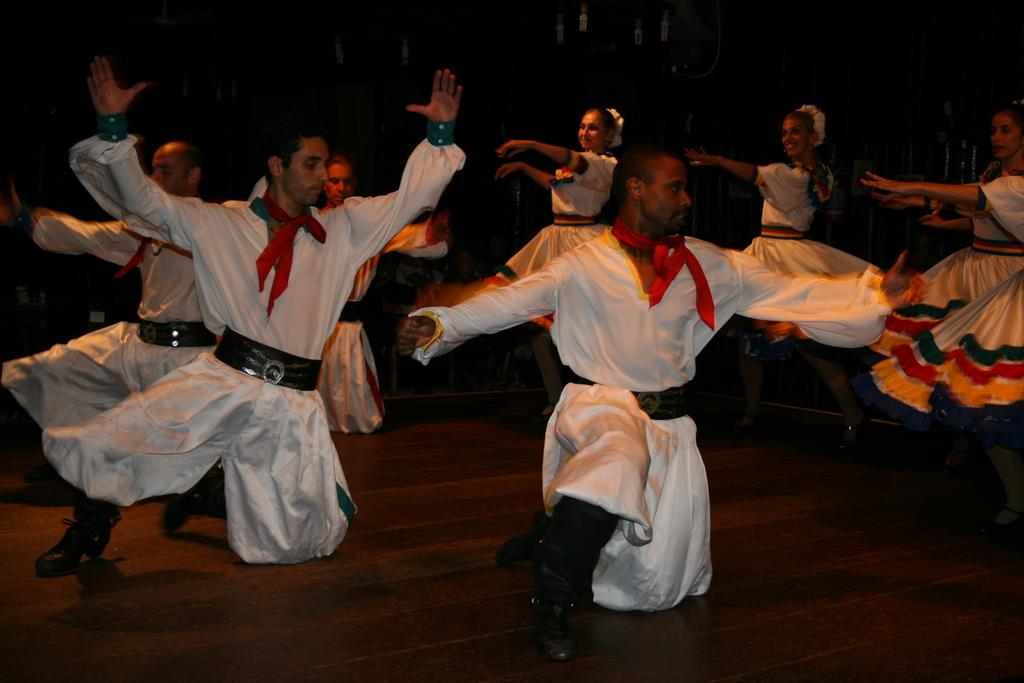What is happening in the image involving a group of people? The people in the image are dancing. What are the people wearing while dancing? The people are wearing white dresses. What type of dinosaurs can be seen in the image? There are no dinosaurs present in the image; it features a group of people dancing in white dresses. 